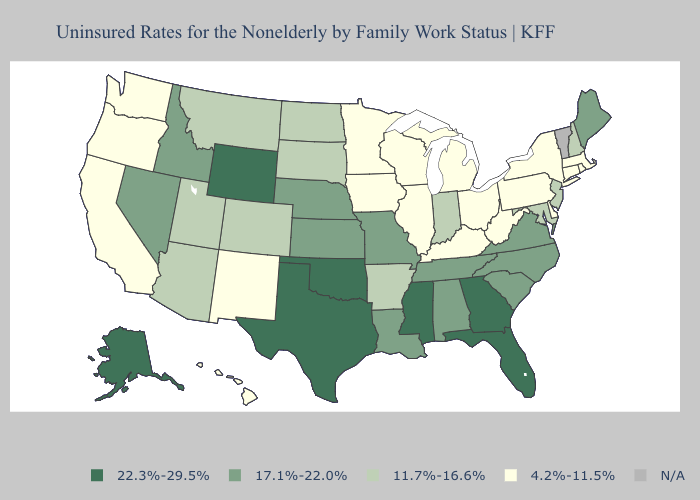What is the lowest value in the USA?
Be succinct. 4.2%-11.5%. Name the states that have a value in the range 22.3%-29.5%?
Give a very brief answer. Alaska, Florida, Georgia, Mississippi, Oklahoma, Texas, Wyoming. Name the states that have a value in the range 22.3%-29.5%?
Concise answer only. Alaska, Florida, Georgia, Mississippi, Oklahoma, Texas, Wyoming. Does the map have missing data?
Give a very brief answer. Yes. Among the states that border Georgia , which have the highest value?
Concise answer only. Florida. Name the states that have a value in the range 22.3%-29.5%?
Concise answer only. Alaska, Florida, Georgia, Mississippi, Oklahoma, Texas, Wyoming. Which states have the lowest value in the USA?
Give a very brief answer. California, Connecticut, Delaware, Hawaii, Illinois, Iowa, Kentucky, Massachusetts, Michigan, Minnesota, New Mexico, New York, Ohio, Oregon, Pennsylvania, Rhode Island, Washington, West Virginia, Wisconsin. Name the states that have a value in the range 22.3%-29.5%?
Short answer required. Alaska, Florida, Georgia, Mississippi, Oklahoma, Texas, Wyoming. Which states have the lowest value in the USA?
Write a very short answer. California, Connecticut, Delaware, Hawaii, Illinois, Iowa, Kentucky, Massachusetts, Michigan, Minnesota, New Mexico, New York, Ohio, Oregon, Pennsylvania, Rhode Island, Washington, West Virginia, Wisconsin. Which states have the lowest value in the USA?
Short answer required. California, Connecticut, Delaware, Hawaii, Illinois, Iowa, Kentucky, Massachusetts, Michigan, Minnesota, New Mexico, New York, Ohio, Oregon, Pennsylvania, Rhode Island, Washington, West Virginia, Wisconsin. Among the states that border New Mexico , does Utah have the lowest value?
Concise answer only. Yes. Name the states that have a value in the range 17.1%-22.0%?
Give a very brief answer. Alabama, Idaho, Kansas, Louisiana, Maine, Missouri, Nebraska, Nevada, North Carolina, South Carolina, Tennessee, Virginia. Name the states that have a value in the range 22.3%-29.5%?
Write a very short answer. Alaska, Florida, Georgia, Mississippi, Oklahoma, Texas, Wyoming. 